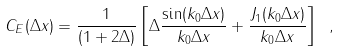<formula> <loc_0><loc_0><loc_500><loc_500>C _ { E } ( \Delta x ) = \frac { 1 } { ( 1 + 2 \Delta ) } \left [ \Delta \frac { \sin ( k _ { 0 } \Delta x ) } { k _ { 0 } \Delta x } + \frac { J _ { 1 } ( k _ { 0 } \Delta x ) } { k _ { 0 } \Delta x } \right ] \ ,</formula> 